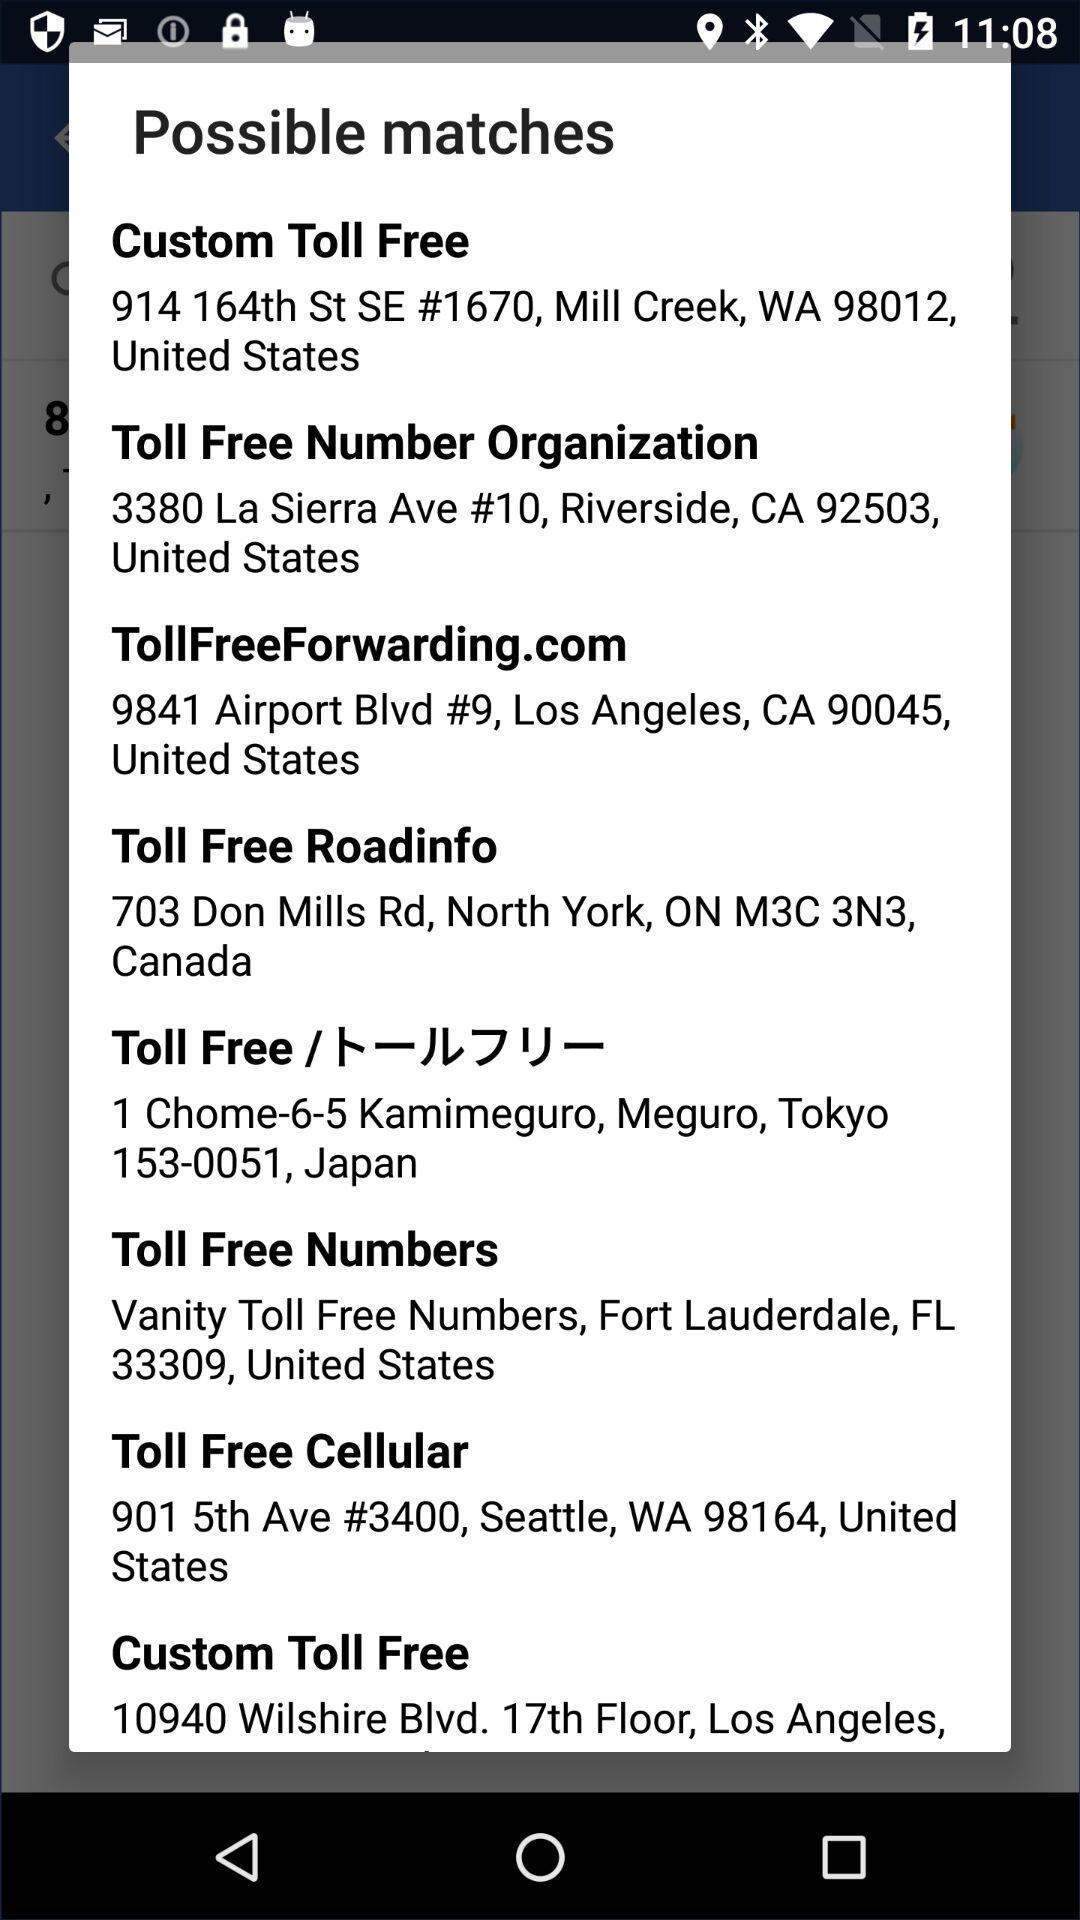What is the name of the application?
When the provided information is insufficient, respond with <no answer>. <no answer> 